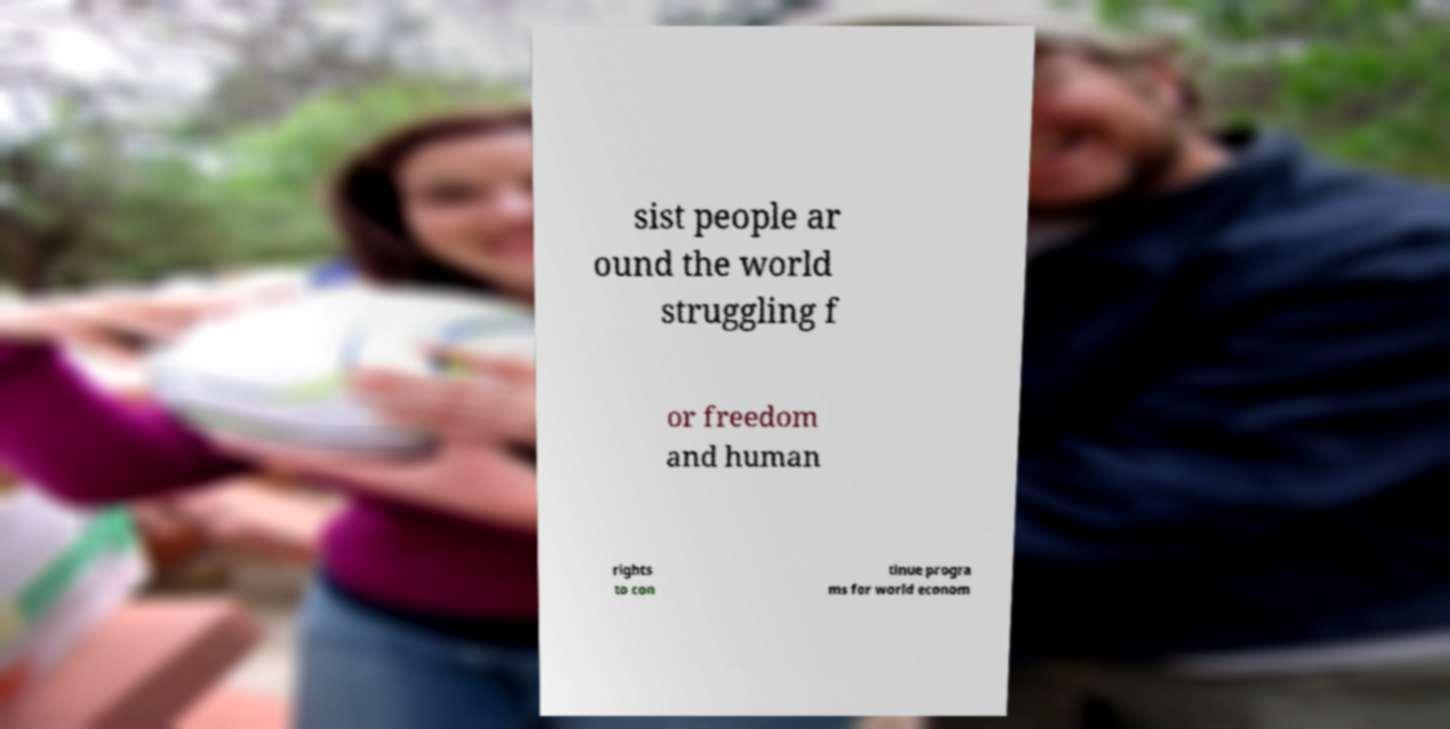Could you extract and type out the text from this image? sist people ar ound the world struggling f or freedom and human rights to con tinue progra ms for world econom 